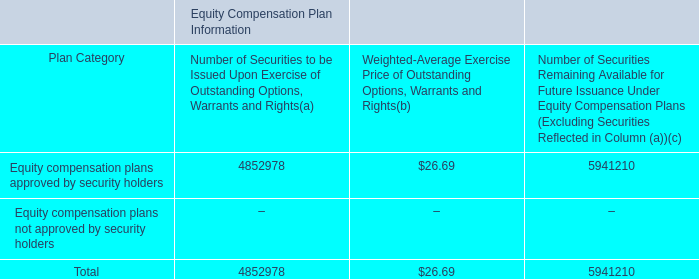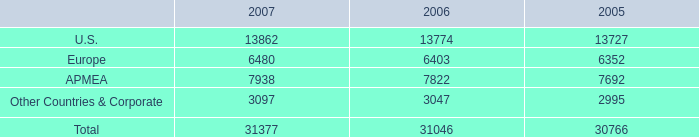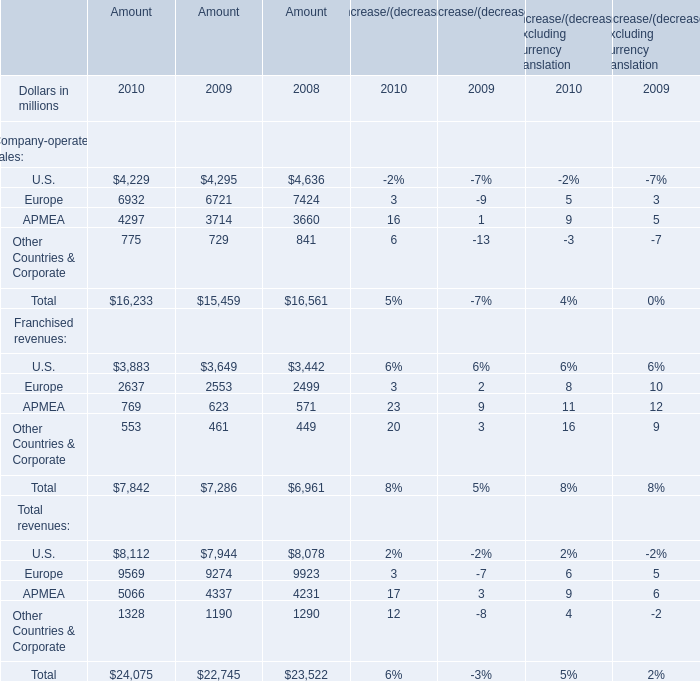In which year is the Amount of Total Franchised revenues smaller than 7000 million? 
Answer: 2008. 